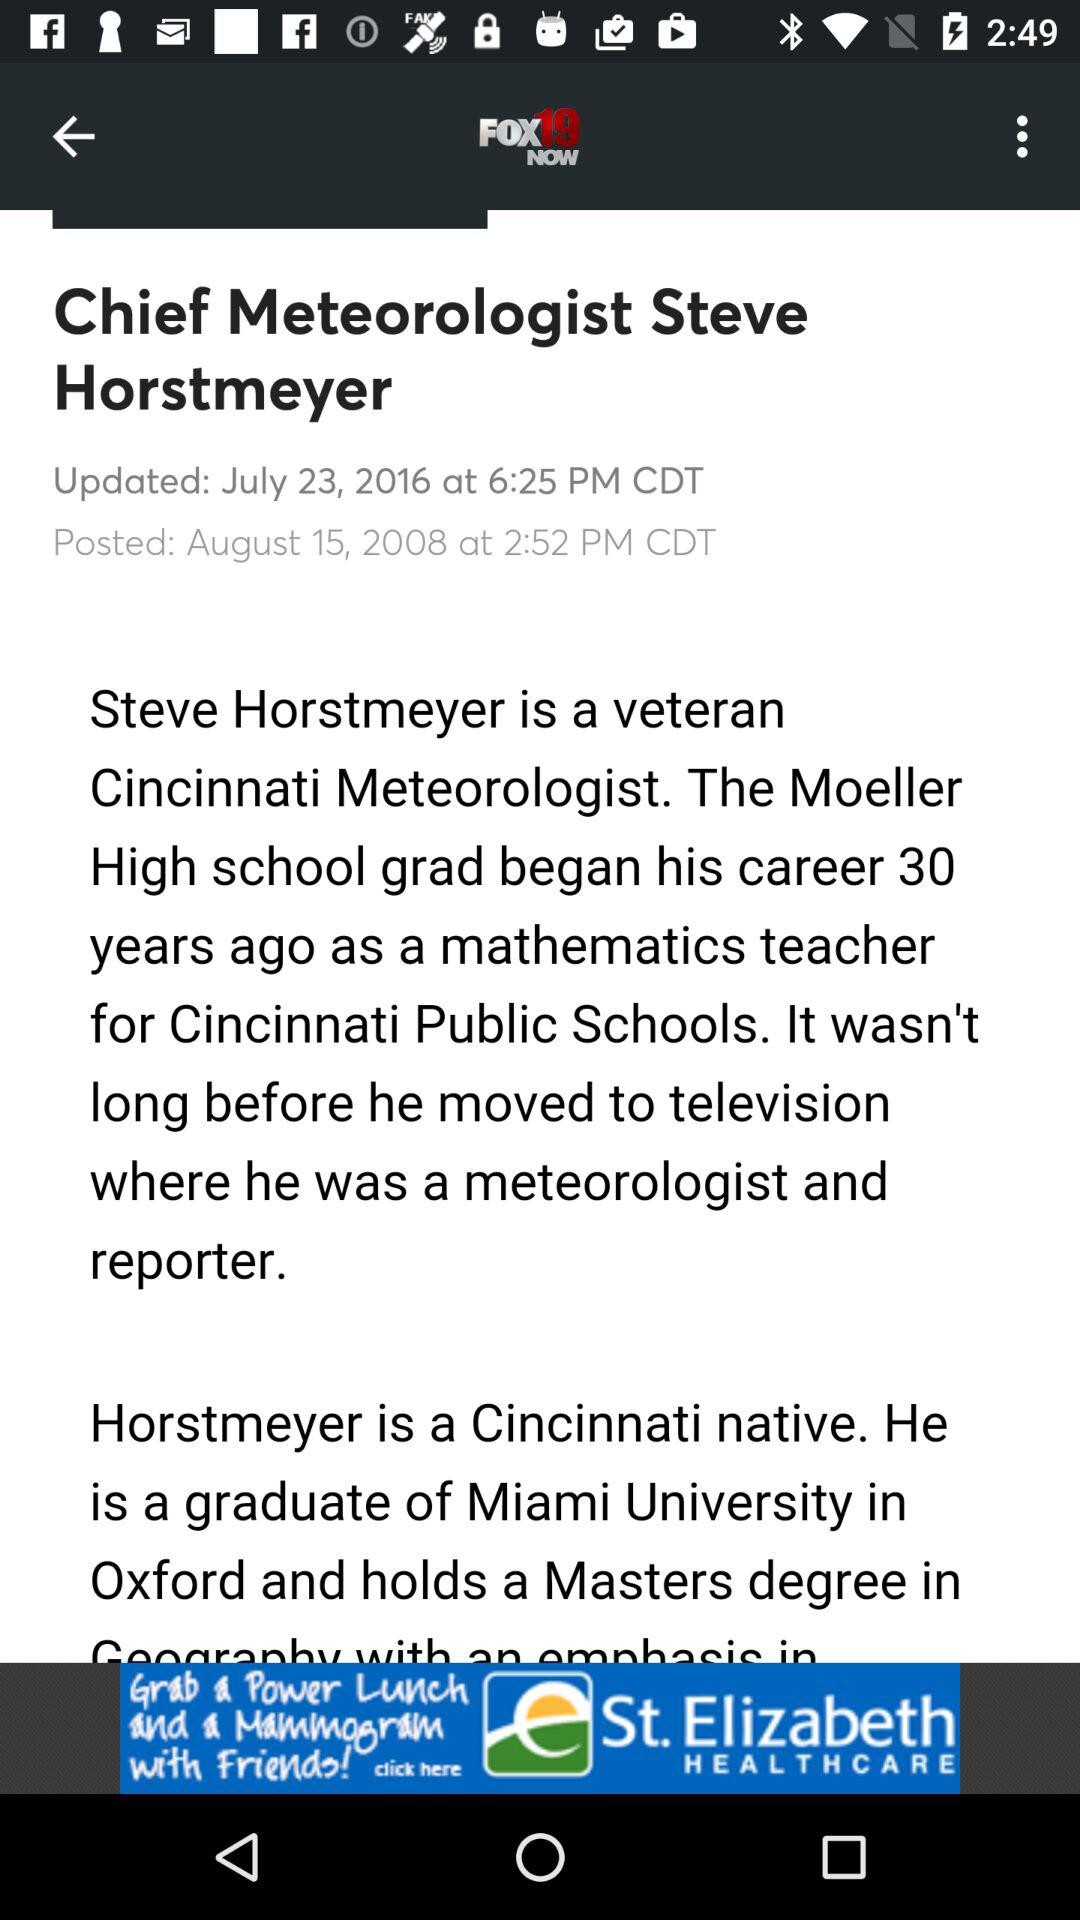What is the posted date? The posted date is August 15, 2008. 